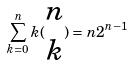Convert formula to latex. <formula><loc_0><loc_0><loc_500><loc_500>\sum _ { k = 0 } ^ { n } k ( \begin{matrix} n \\ k \end{matrix} ) = n 2 ^ { n - 1 }</formula> 